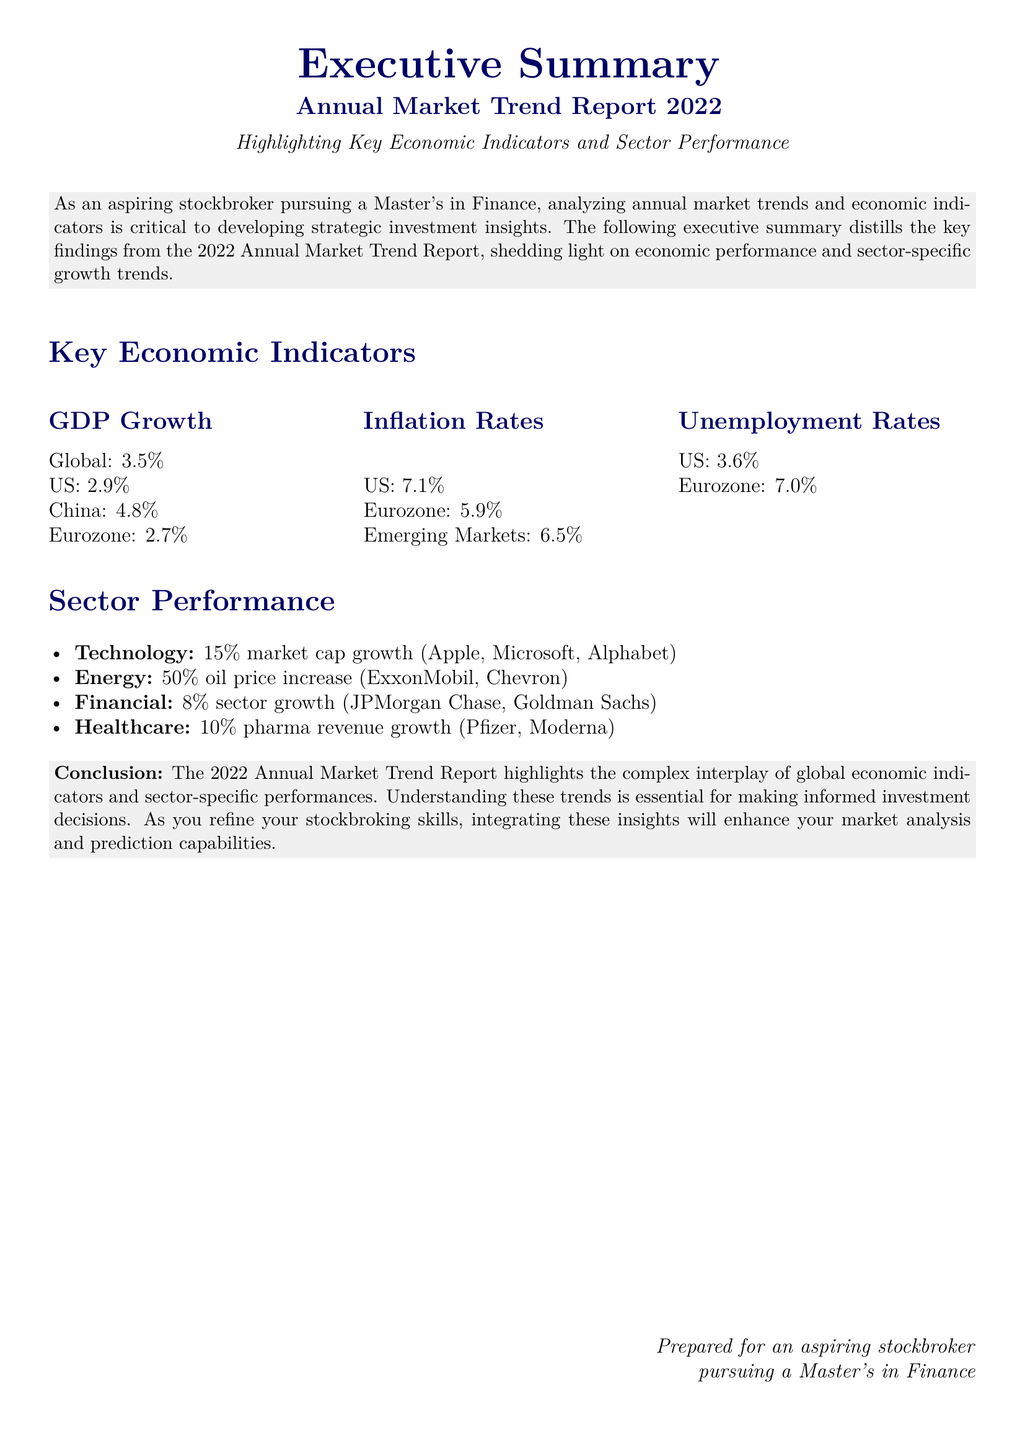What is the global GDP growth rate for 2022? The document states that the global GDP growth rate is 3.5%.
Answer: 3.5% What was the inflation rate in the US for 2022? According to the report, the inflation rate in the US was 7.1%.
Answer: 7.1% Which sector experienced a 50% increase in oil prices? The document mentions that the Energy sector experienced a 50% oil price increase.
Answer: Energy What is the unemployment rate in the Eurozone? The document indicates that the unemployment rate in the Eurozone is 7.0%.
Answer: 7.0% What was the market cap growth percentage for the Technology sector? The report highlights that the Technology sector saw a 15% market cap growth.
Answer: 15% How much did the Financial sector grow in 2022? The document reports an 8% sector growth for Financials.
Answer: 8% Which two companies are mentioned under the Technology sector? The document lists Apple and Microsoft as companies in the Technology sector.
Answer: Apple, Microsoft What is the key conclusion of the report? The conclusion summarizes the importance of understanding global economic indicators and sector performance for informed investment decisions.
Answer: Informed investment decisions In which year was the Annual Market Trend Report prepared? The document clearly states that the report is from the year 2022.
Answer: 2022 What type of document is this? This document is an Executive Summary of an Annual Market Trend Report.
Answer: Executive Summary 